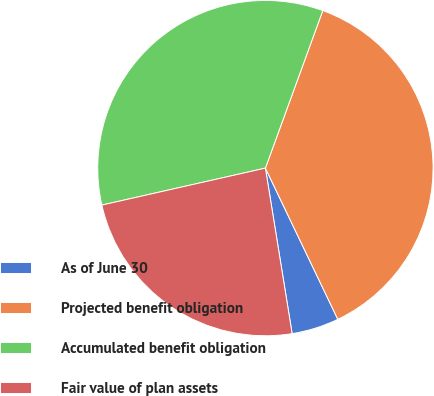<chart> <loc_0><loc_0><loc_500><loc_500><pie_chart><fcel>As of June 30<fcel>Projected benefit obligation<fcel>Accumulated benefit obligation<fcel>Fair value of plan assets<nl><fcel>4.56%<fcel>37.33%<fcel>34.1%<fcel>24.01%<nl></chart> 